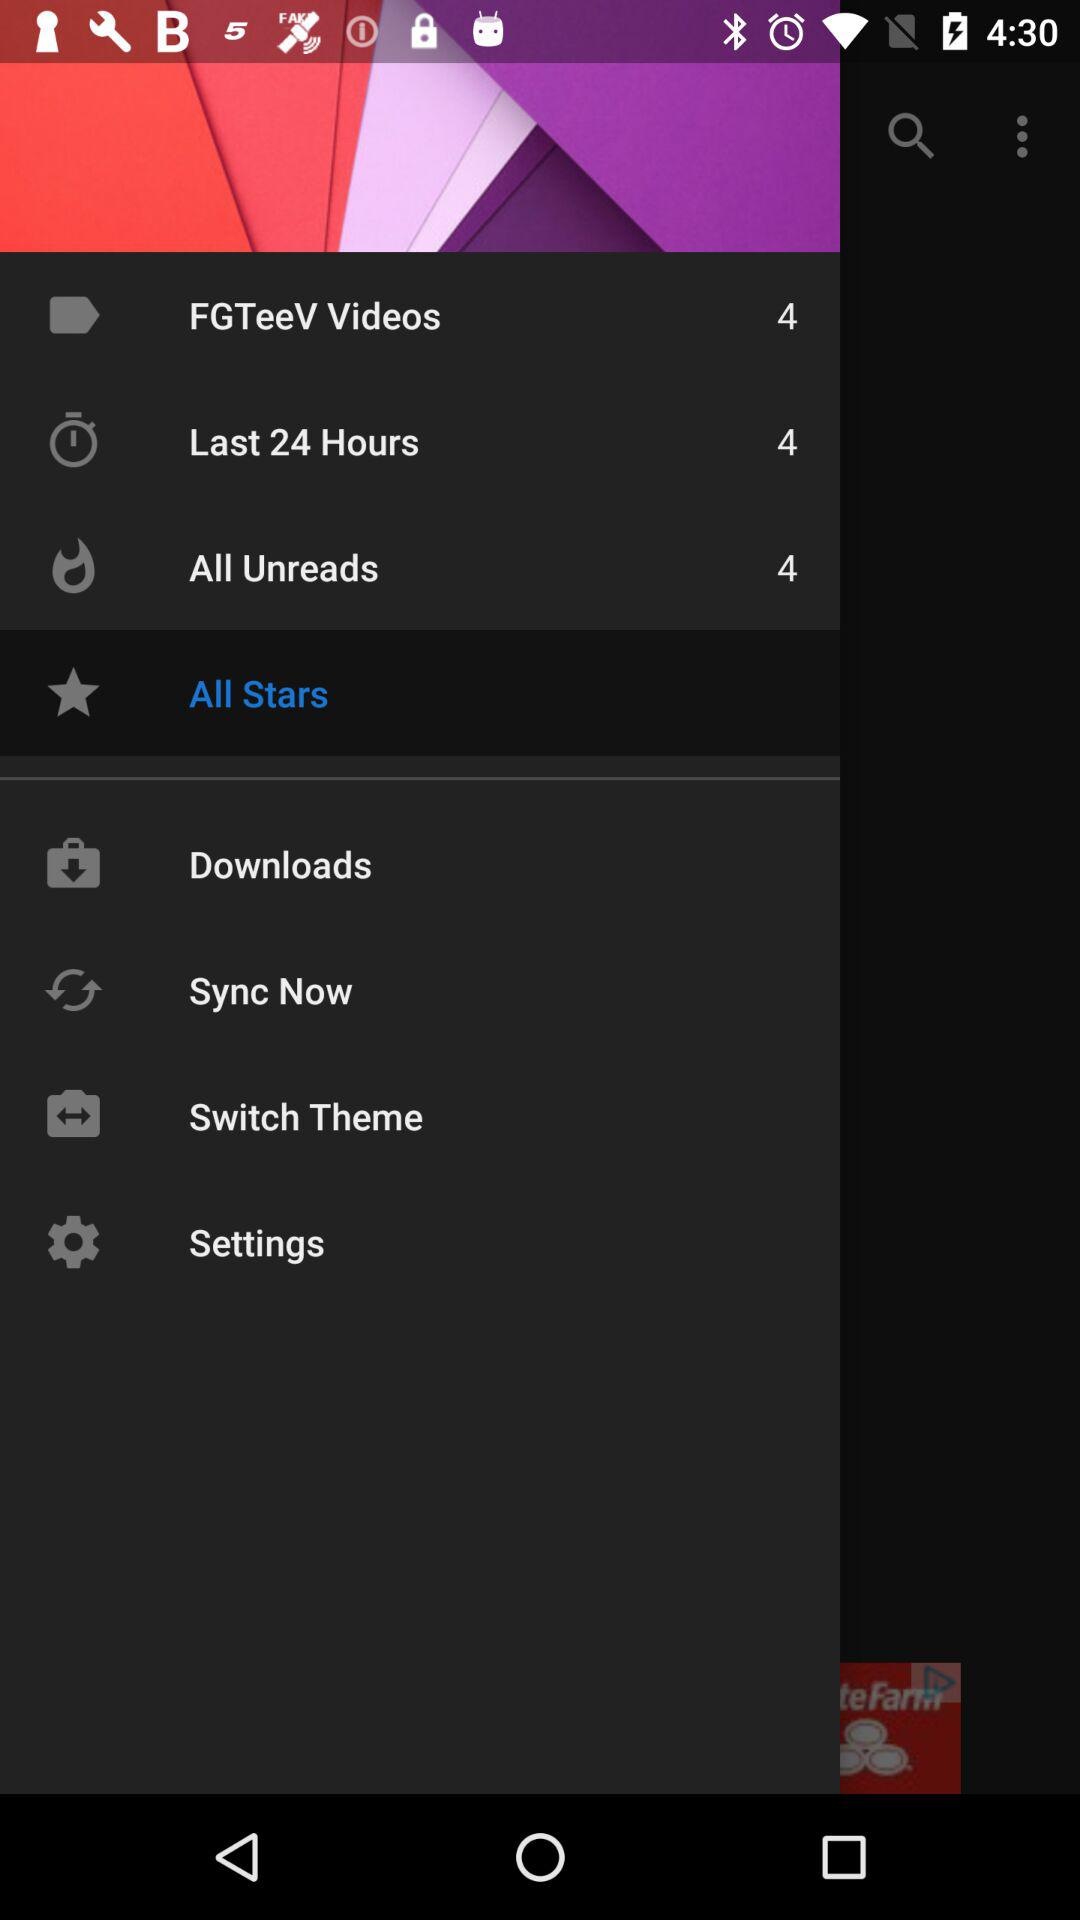What is the count for "All Unreads"? The count for "All Unreads" is 4. 